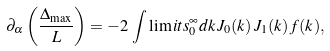Convert formula to latex. <formula><loc_0><loc_0><loc_500><loc_500>\partial _ { \alpha } \left ( \frac { \Delta _ { \max } } { L } \right ) = - 2 \, \int \lim i t s _ { 0 } ^ { \infty } d k \, J _ { 0 } ( k ) \, J _ { 1 } ( k ) \, f ( k ) ,</formula> 